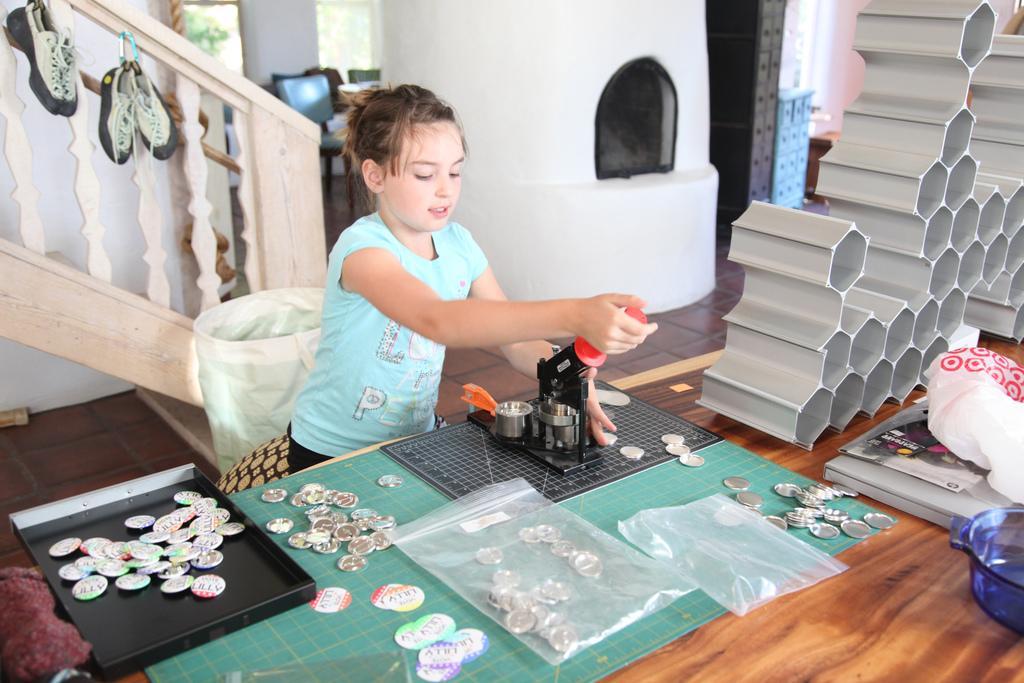How would you summarize this image in a sentence or two? In this picture we can see a person. This is table. On the table there are covers and coins. This is floor and there is a wall. 